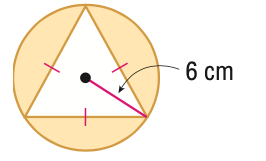Question: Find the area of the shaded region. Round to the nearest tenth.
Choices:
A. 19.6
B. 46.8
C. 66.3
D. 113.1
Answer with the letter. Answer: C 